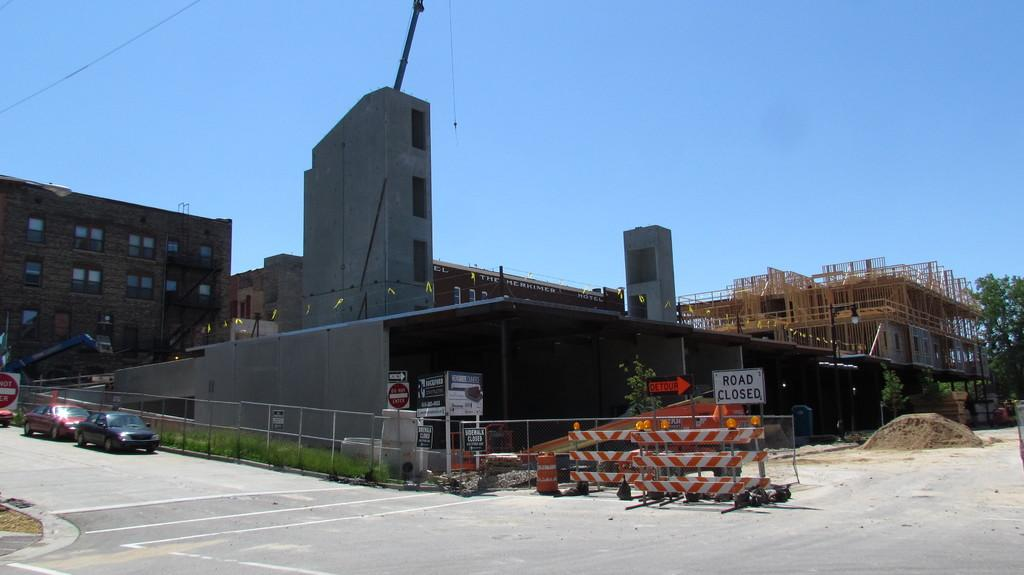What type of structures can be seen in the image? There are buildings in the image. What other natural elements are present in the image? There are trees in the image. What is at the bottom of the image? There is a road at the bottom of the image. What vehicles can be seen on the road? Cars are visible on the road. What additional objects can be found in the image? There are boards and railings present in the image. What can be seen in the background of the image? The sky is visible in the background of the image. What advice does the butter give to the uncle in the image? There is no butter or uncle present in the image, so no such interaction can be observed. 